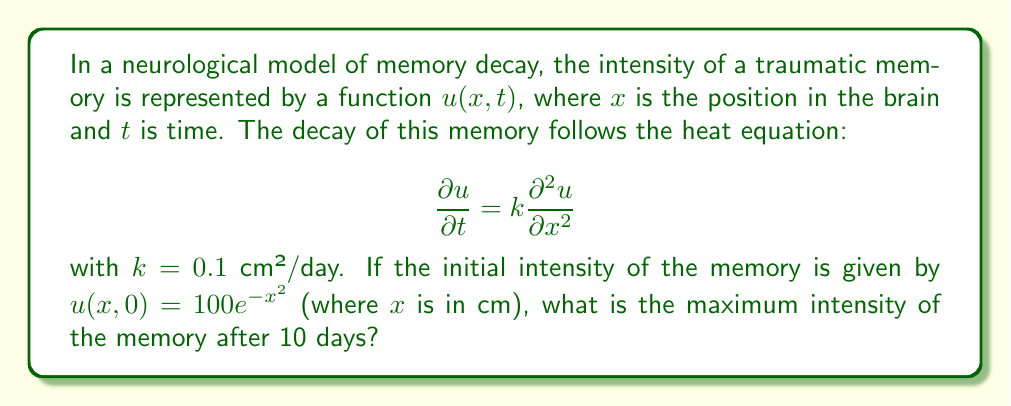Can you answer this question? To solve this problem, we'll use the fundamental solution of the heat equation:

1) The general solution for the 1D heat equation with initial condition $u(x,0) = f(x)$ is:

   $$u(x,t) = \frac{1}{\sqrt{4\pi kt}} \int_{-\infty}^{\infty} f(\xi) e^{-\frac{(x-\xi)^2}{4kt}} d\xi$$

2) In our case, $f(x) = 100e^{-x^2}$, $k = 0.1$ cm²/day, and $t = 10$ days.

3) Substituting these into the solution:

   $$u(x,10) = \frac{100}{\sqrt{4\pi(0.1)(10)}} \int_{-\infty}^{\infty} e^{-\xi^2} e^{-\frac{(x-\xi)^2}{4(0.1)(10)}} d\xi$$

4) Simplify:

   $$u(x,10) = \frac{100}{\sqrt{4\pi}} \int_{-\infty}^{\infty} e^{-\xi^2} e^{-\frac{(x-\xi)^2}{4}} d\xi$$

5) This integral can be evaluated to:

   $$u(x,10) = \frac{100}{\sqrt{5}} e^{-\frac{x^2}{5}}$$

6) To find the maximum intensity, we need to find the maximum value of this function. The maximum occurs at $x = 0$ (center of the brain in this model).

7) Evaluate at $x = 0$:

   $$u(0,10) = \frac{100}{\sqrt{5}} \approx 44.72$$

Thus, the maximum intensity after 10 days is approximately 44.72.
Answer: 44.72 